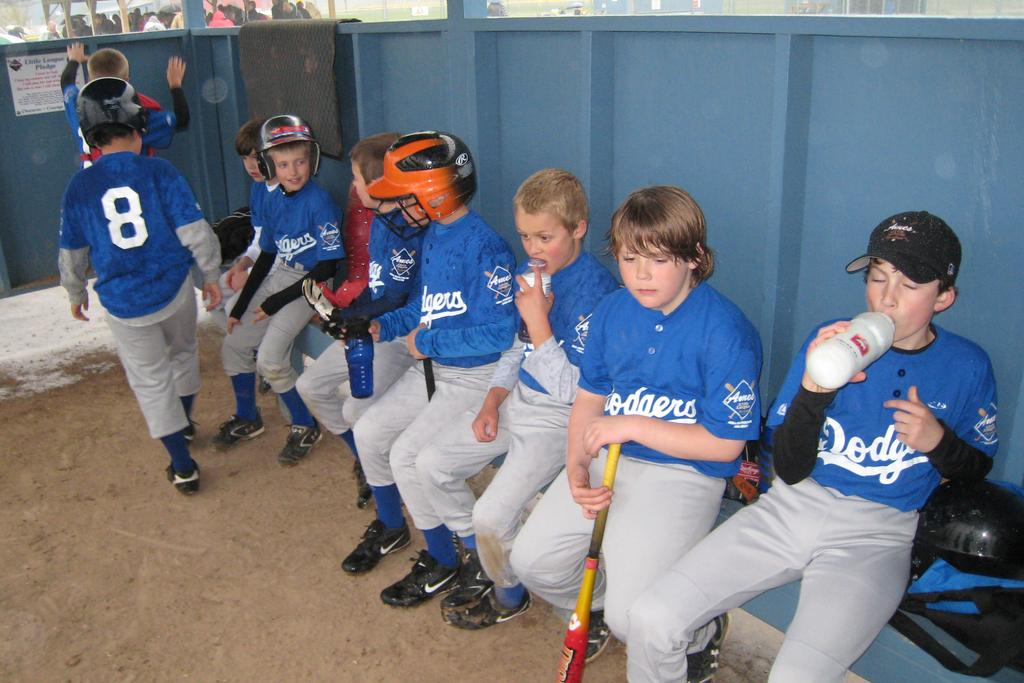<image>
Provide a brief description of the given image. Kids in Dodgers uniforms sit in the dugout. 